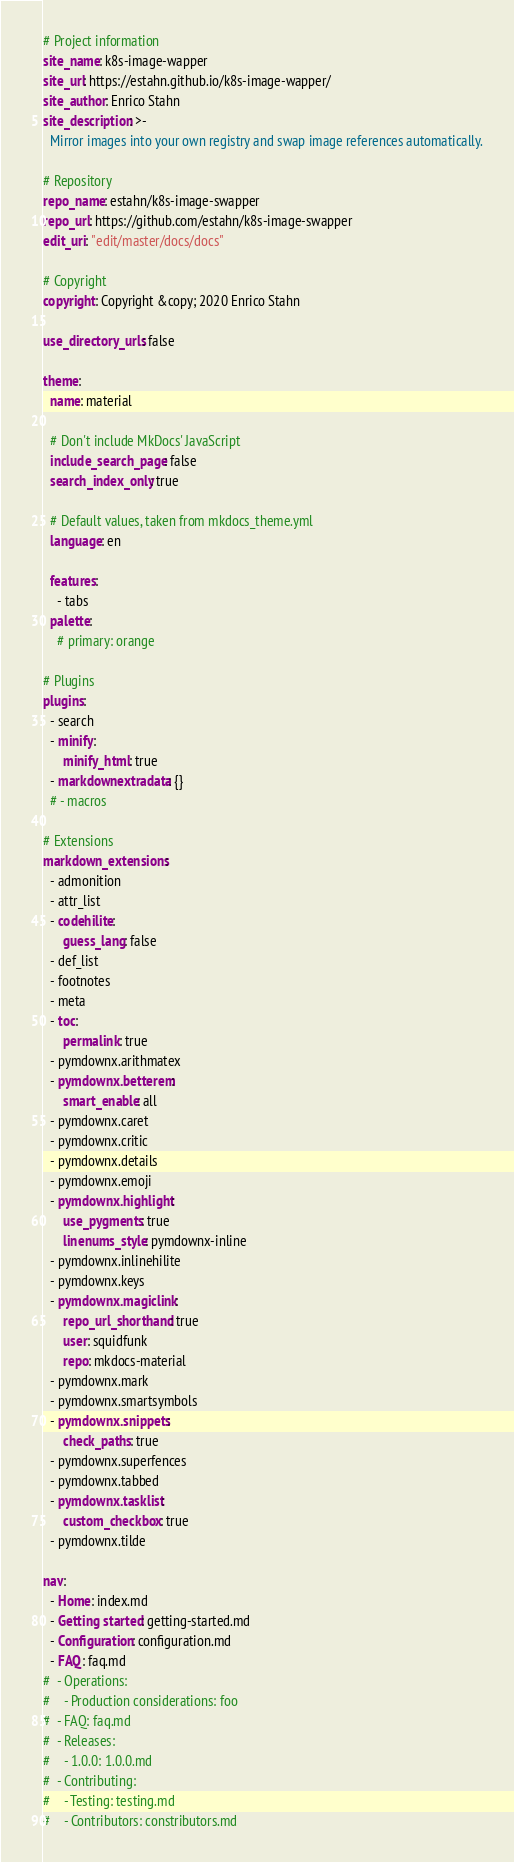<code> <loc_0><loc_0><loc_500><loc_500><_YAML_># Project information
site_name: k8s-image-wapper
site_url: https://estahn.github.io/k8s-image-wapper/
site_author: Enrico Stahn
site_description: >-
  Mirror images into your own registry and swap image references automatically.

# Repository
repo_name: estahn/k8s-image-swapper
repo_url: https://github.com/estahn/k8s-image-swapper
edit_uri: "edit/master/docs/docs"

# Copyright
copyright: Copyright &copy; 2020 Enrico Stahn

use_directory_urls: false

theme:
  name: material

  # Don't include MkDocs' JavaScript
  include_search_page: false
  search_index_only: true

  # Default values, taken from mkdocs_theme.yml
  language: en

  features:
    - tabs
  palette:
    # primary: orange

# Plugins
plugins:
  - search
  - minify:
      minify_html: true
  - markdownextradata: {}
  # - macros

# Extensions
markdown_extensions:
  - admonition
  - attr_list
  - codehilite:
      guess_lang: false
  - def_list
  - footnotes
  - meta
  - toc:
      permalink: true
  - pymdownx.arithmatex
  - pymdownx.betterem:
      smart_enable: all
  - pymdownx.caret
  - pymdownx.critic
  - pymdownx.details
  - pymdownx.emoji
  - pymdownx.highlight:
      use_pygments: true
      linenums_style: pymdownx-inline
  - pymdownx.inlinehilite
  - pymdownx.keys
  - pymdownx.magiclink:
      repo_url_shorthand: true
      user: squidfunk
      repo: mkdocs-material
  - pymdownx.mark
  - pymdownx.smartsymbols
  - pymdownx.snippets:
      check_paths: true
  - pymdownx.superfences
  - pymdownx.tabbed
  - pymdownx.tasklist:
      custom_checkbox: true
  - pymdownx.tilde

nav:
  - Home: index.md
  - Getting started: getting-started.md
  - Configuration: configuration.md
  - FAQ: faq.md
#  - Operations:
#    - Production considerations: foo
#  - FAQ: faq.md
#  - Releases:
#    - 1.0.0: 1.0.0.md
#  - Contributing:
#    - Testing: testing.md
#    - Contributors: constributors.md
</code> 